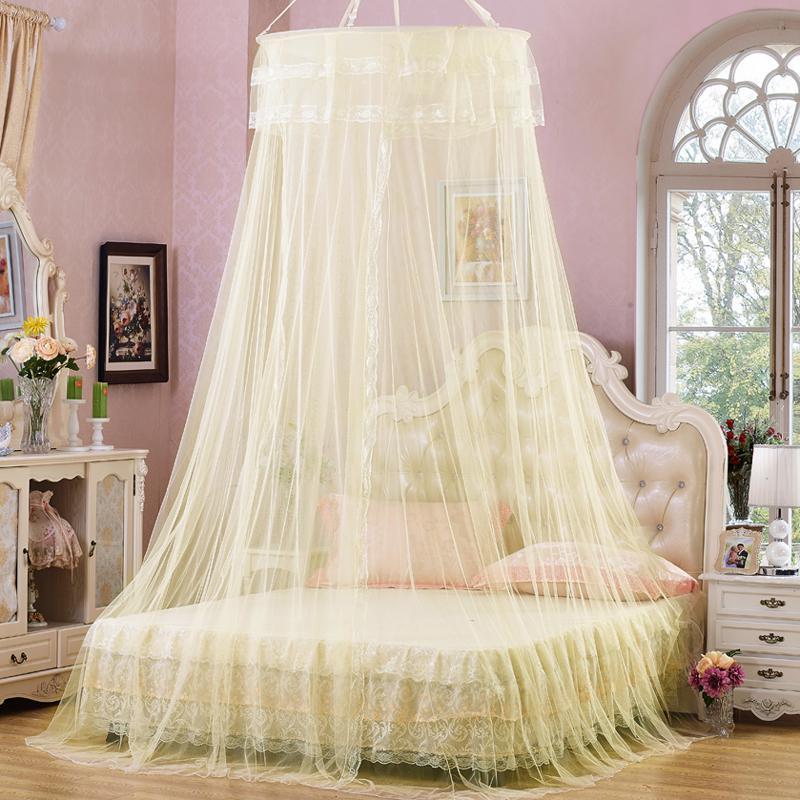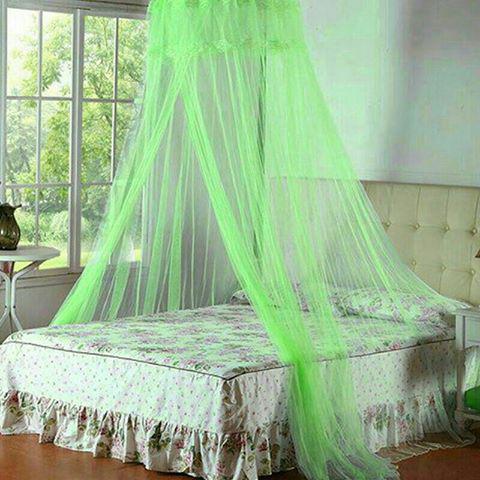The first image is the image on the left, the second image is the image on the right. Given the left and right images, does the statement "All of the bed nets are purple." hold true? Answer yes or no. No. The first image is the image on the left, the second image is the image on the right. Assess this claim about the two images: "There are two purple bed canopies with headboards that are visible through them.". Correct or not? Answer yes or no. No. 